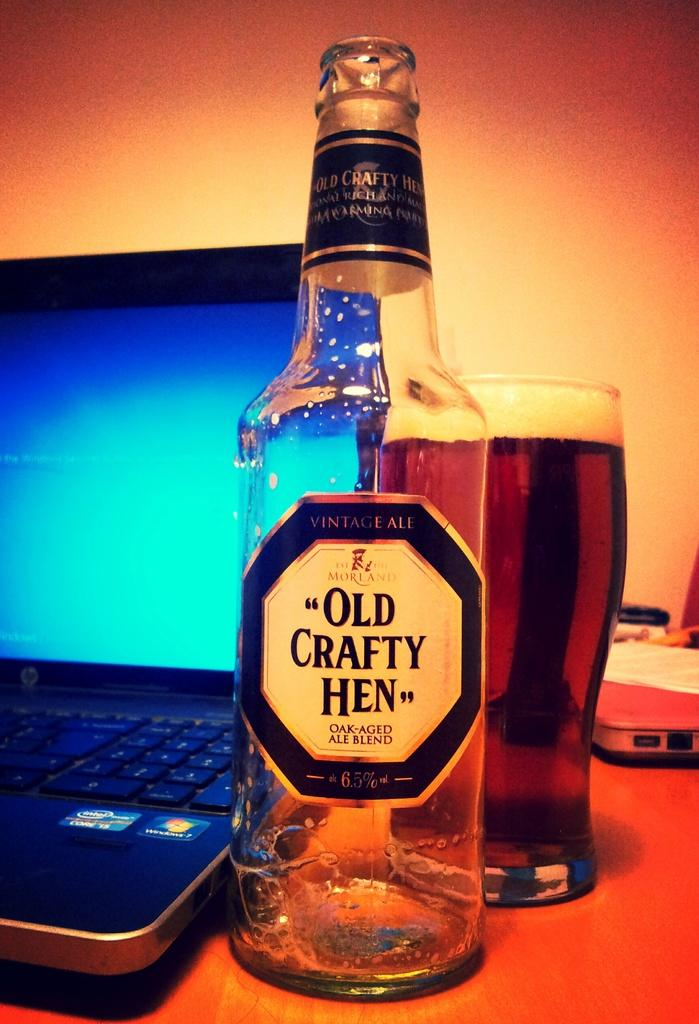<image>
Summarize the visual content of the image. A laptop, a glass of beer and an "Old Crafty Hen" beer bottle. 